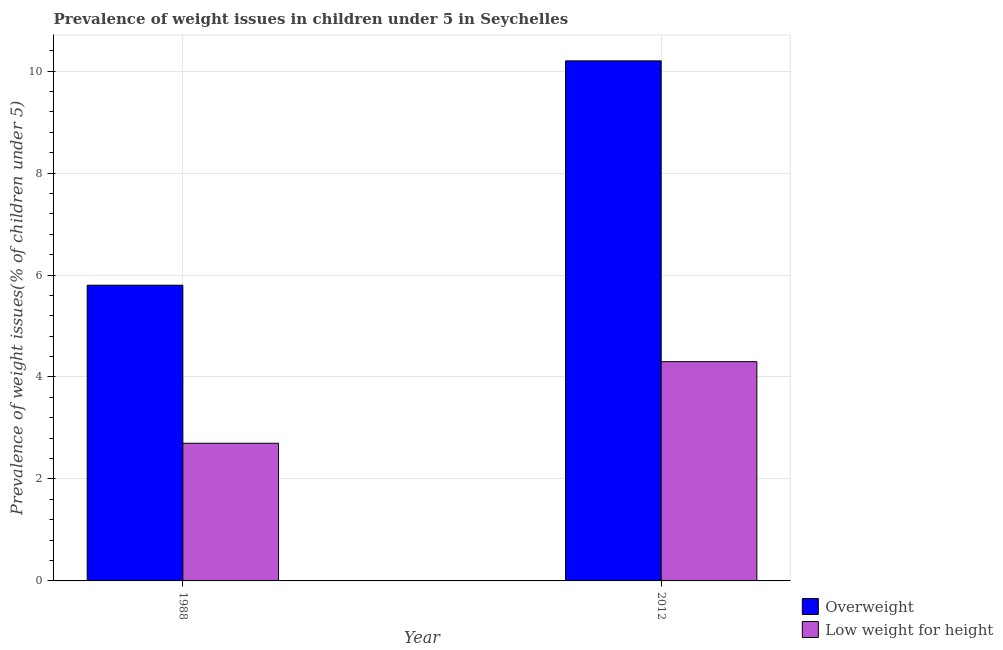Are the number of bars on each tick of the X-axis equal?
Provide a succinct answer. Yes. How many bars are there on the 2nd tick from the left?
Provide a short and direct response. 2. How many bars are there on the 1st tick from the right?
Make the answer very short. 2. What is the percentage of underweight children in 2012?
Provide a short and direct response. 4.3. Across all years, what is the maximum percentage of overweight children?
Your answer should be compact. 10.2. Across all years, what is the minimum percentage of underweight children?
Provide a short and direct response. 2.7. In which year was the percentage of underweight children maximum?
Ensure brevity in your answer.  2012. In which year was the percentage of overweight children minimum?
Provide a succinct answer. 1988. What is the total percentage of overweight children in the graph?
Your answer should be very brief. 16. What is the difference between the percentage of overweight children in 1988 and that in 2012?
Your response must be concise. -4.4. What is the difference between the percentage of underweight children in 1988 and the percentage of overweight children in 2012?
Provide a short and direct response. -1.6. What is the average percentage of underweight children per year?
Ensure brevity in your answer.  3.5. In how many years, is the percentage of underweight children greater than 6.8 %?
Offer a terse response. 0. What is the ratio of the percentage of overweight children in 1988 to that in 2012?
Keep it short and to the point. 0.57. What does the 2nd bar from the left in 2012 represents?
Ensure brevity in your answer.  Low weight for height. What does the 2nd bar from the right in 1988 represents?
Keep it short and to the point. Overweight. How many years are there in the graph?
Your answer should be very brief. 2. What is the difference between two consecutive major ticks on the Y-axis?
Provide a short and direct response. 2. What is the title of the graph?
Offer a terse response. Prevalence of weight issues in children under 5 in Seychelles. Does "From human activities" appear as one of the legend labels in the graph?
Provide a short and direct response. No. What is the label or title of the X-axis?
Your response must be concise. Year. What is the label or title of the Y-axis?
Offer a terse response. Prevalence of weight issues(% of children under 5). What is the Prevalence of weight issues(% of children under 5) in Overweight in 1988?
Give a very brief answer. 5.8. What is the Prevalence of weight issues(% of children under 5) of Low weight for height in 1988?
Make the answer very short. 2.7. What is the Prevalence of weight issues(% of children under 5) of Overweight in 2012?
Offer a very short reply. 10.2. What is the Prevalence of weight issues(% of children under 5) in Low weight for height in 2012?
Offer a very short reply. 4.3. Across all years, what is the maximum Prevalence of weight issues(% of children under 5) in Overweight?
Give a very brief answer. 10.2. Across all years, what is the maximum Prevalence of weight issues(% of children under 5) in Low weight for height?
Offer a terse response. 4.3. Across all years, what is the minimum Prevalence of weight issues(% of children under 5) in Overweight?
Make the answer very short. 5.8. Across all years, what is the minimum Prevalence of weight issues(% of children under 5) of Low weight for height?
Your response must be concise. 2.7. What is the total Prevalence of weight issues(% of children under 5) of Overweight in the graph?
Your answer should be compact. 16. What is the difference between the Prevalence of weight issues(% of children under 5) of Overweight in 1988 and that in 2012?
Keep it short and to the point. -4.4. What is the average Prevalence of weight issues(% of children under 5) of Overweight per year?
Make the answer very short. 8. What is the average Prevalence of weight issues(% of children under 5) in Low weight for height per year?
Keep it short and to the point. 3.5. In the year 2012, what is the difference between the Prevalence of weight issues(% of children under 5) of Overweight and Prevalence of weight issues(% of children under 5) of Low weight for height?
Offer a very short reply. 5.9. What is the ratio of the Prevalence of weight issues(% of children under 5) in Overweight in 1988 to that in 2012?
Your response must be concise. 0.57. What is the ratio of the Prevalence of weight issues(% of children under 5) of Low weight for height in 1988 to that in 2012?
Provide a succinct answer. 0.63. What is the difference between the highest and the second highest Prevalence of weight issues(% of children under 5) in Overweight?
Your answer should be compact. 4.4. What is the difference between the highest and the second highest Prevalence of weight issues(% of children under 5) in Low weight for height?
Ensure brevity in your answer.  1.6. What is the difference between the highest and the lowest Prevalence of weight issues(% of children under 5) of Overweight?
Ensure brevity in your answer.  4.4. What is the difference between the highest and the lowest Prevalence of weight issues(% of children under 5) in Low weight for height?
Your answer should be compact. 1.6. 